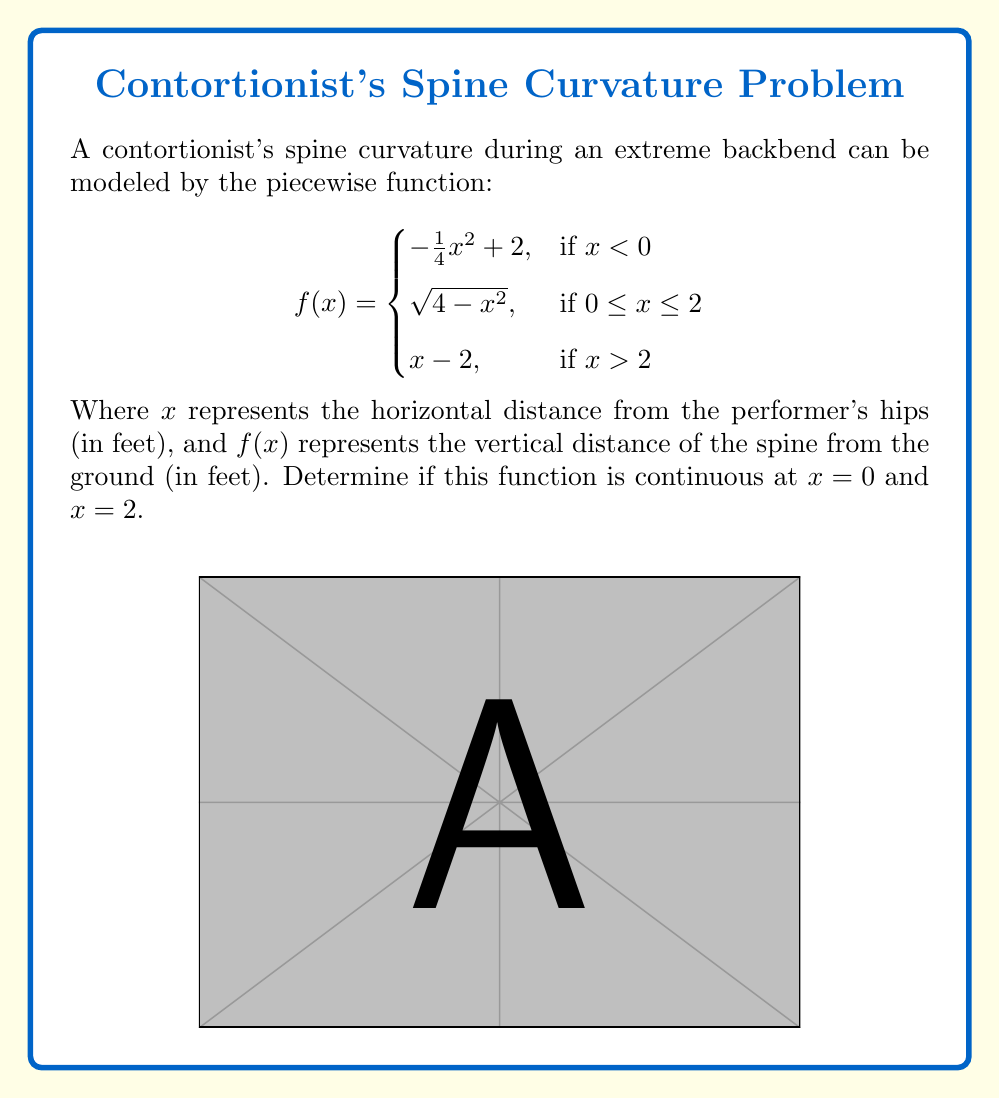Can you solve this math problem? To determine continuity at $x=0$ and $x=2$, we need to check three conditions at each point:
1. The function is defined at the point
2. The limit of the function as we approach the point from both sides exists
3. The limit equals the function value at that point

For $x=0$:
1. $f(0)$ is defined: $f(0) = \sqrt{4-0^2} = 2$
2. Left limit: 
   $\lim_{x \to 0^-} f(x) = \lim_{x \to 0^-} (-\frac{1}{4}x^2 + 2) = 2$
   Right limit:
   $\lim_{x \to 0^+} f(x) = \lim_{x \to 0^+} \sqrt{4-x^2} = 2$
3. $f(0) = \lim_{x \to 0^-} f(x) = \lim_{x \to 0^+} f(x) = 2$

Therefore, $f(x)$ is continuous at $x=0$.

For $x=2$:
1. $f(2)$ is defined: $f(2) = \sqrt{4-2^2} = 0$
2. Left limit:
   $\lim_{x \to 2^-} f(x) = \lim_{x \to 2^-} \sqrt{4-x^2} = 0$
   Right limit:
   $\lim_{x \to 2^+} f(x) = \lim_{x \to 2^+} (x-2) = 0$
3. $f(2) = \lim_{x \to 2^-} f(x) = \lim_{x \to 2^+} f(x) = 0$

Therefore, $f(x)$ is continuous at $x=2$.
Answer: $f(x)$ is continuous at both $x=0$ and $x=2$. 